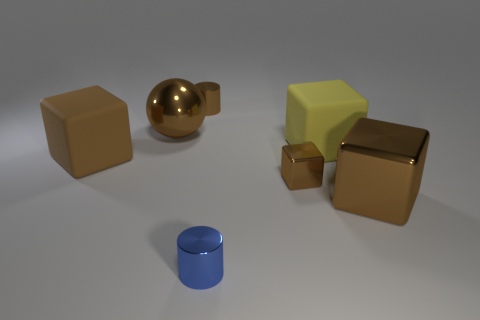Is the number of tiny blue metallic things in front of the small blue shiny cylinder less than the number of tiny things that are on the right side of the brown rubber thing?
Your answer should be very brief. Yes. There is a small blue thing that is the same material as the large sphere; what shape is it?
Ensure brevity in your answer.  Cylinder. There is a block that is on the left side of the small shiny object that is in front of the large metal object that is in front of the brown rubber block; what is its size?
Provide a succinct answer. Large. Are there more small blue shiny objects than small brown shiny spheres?
Your answer should be compact. Yes. Does the big object behind the large yellow object have the same color as the small metal cylinder behind the large brown rubber object?
Keep it short and to the point. Yes. Does the brown cube that is to the right of the yellow cube have the same material as the large block that is left of the big sphere?
Keep it short and to the point. No. What number of other things are the same size as the yellow rubber object?
Ensure brevity in your answer.  3. Are there fewer large yellow objects than large brown shiny objects?
Give a very brief answer. Yes. The tiny brown object on the right side of the small cylinder in front of the brown cylinder is what shape?
Make the answer very short. Cube. The rubber thing that is the same size as the brown matte cube is what shape?
Provide a short and direct response. Cube. 